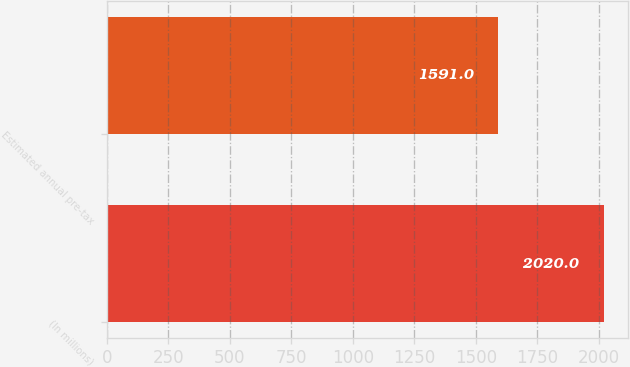Convert chart to OTSL. <chart><loc_0><loc_0><loc_500><loc_500><bar_chart><fcel>(In millions)<fcel>Estimated annual pre-tax<nl><fcel>2020<fcel>1591<nl></chart> 